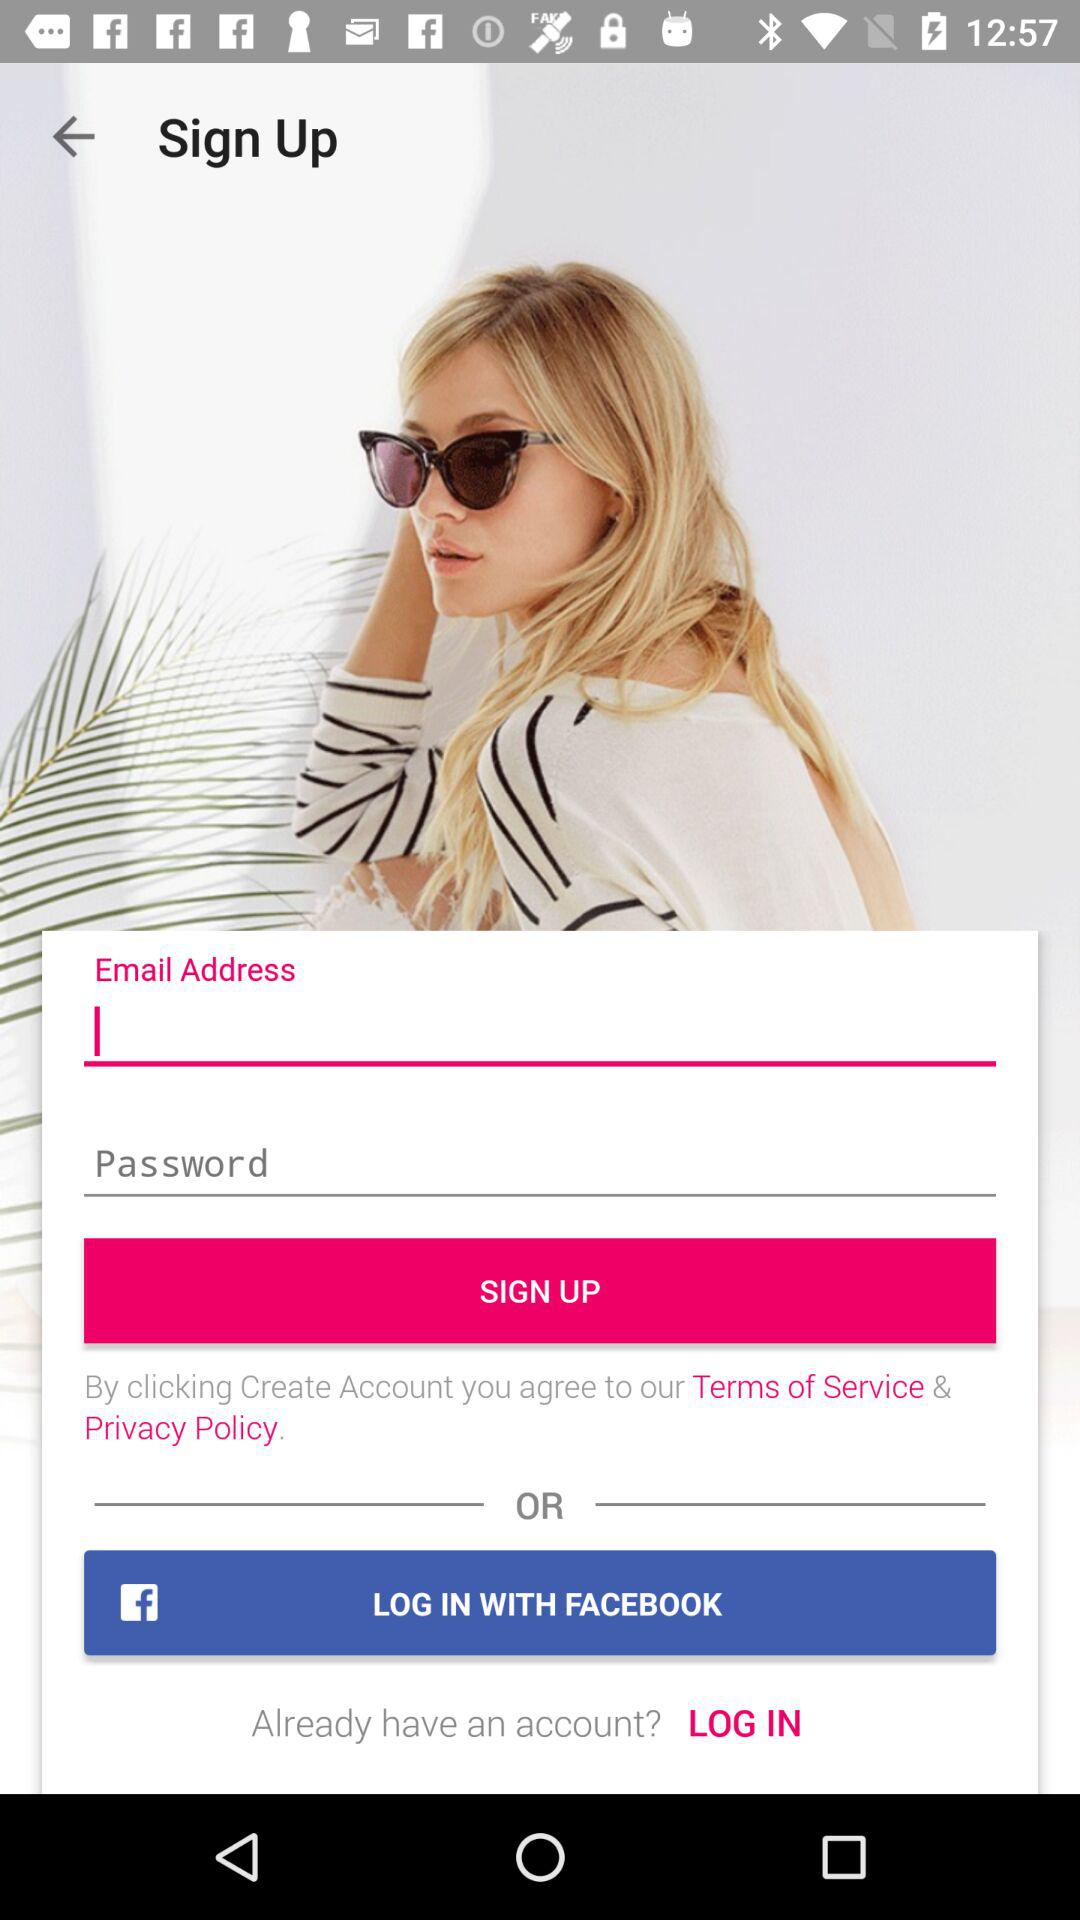What social media accounts can be used to sign up? The social media account that can be used to sign up is "LOG IN WITH FACEBOOK". 